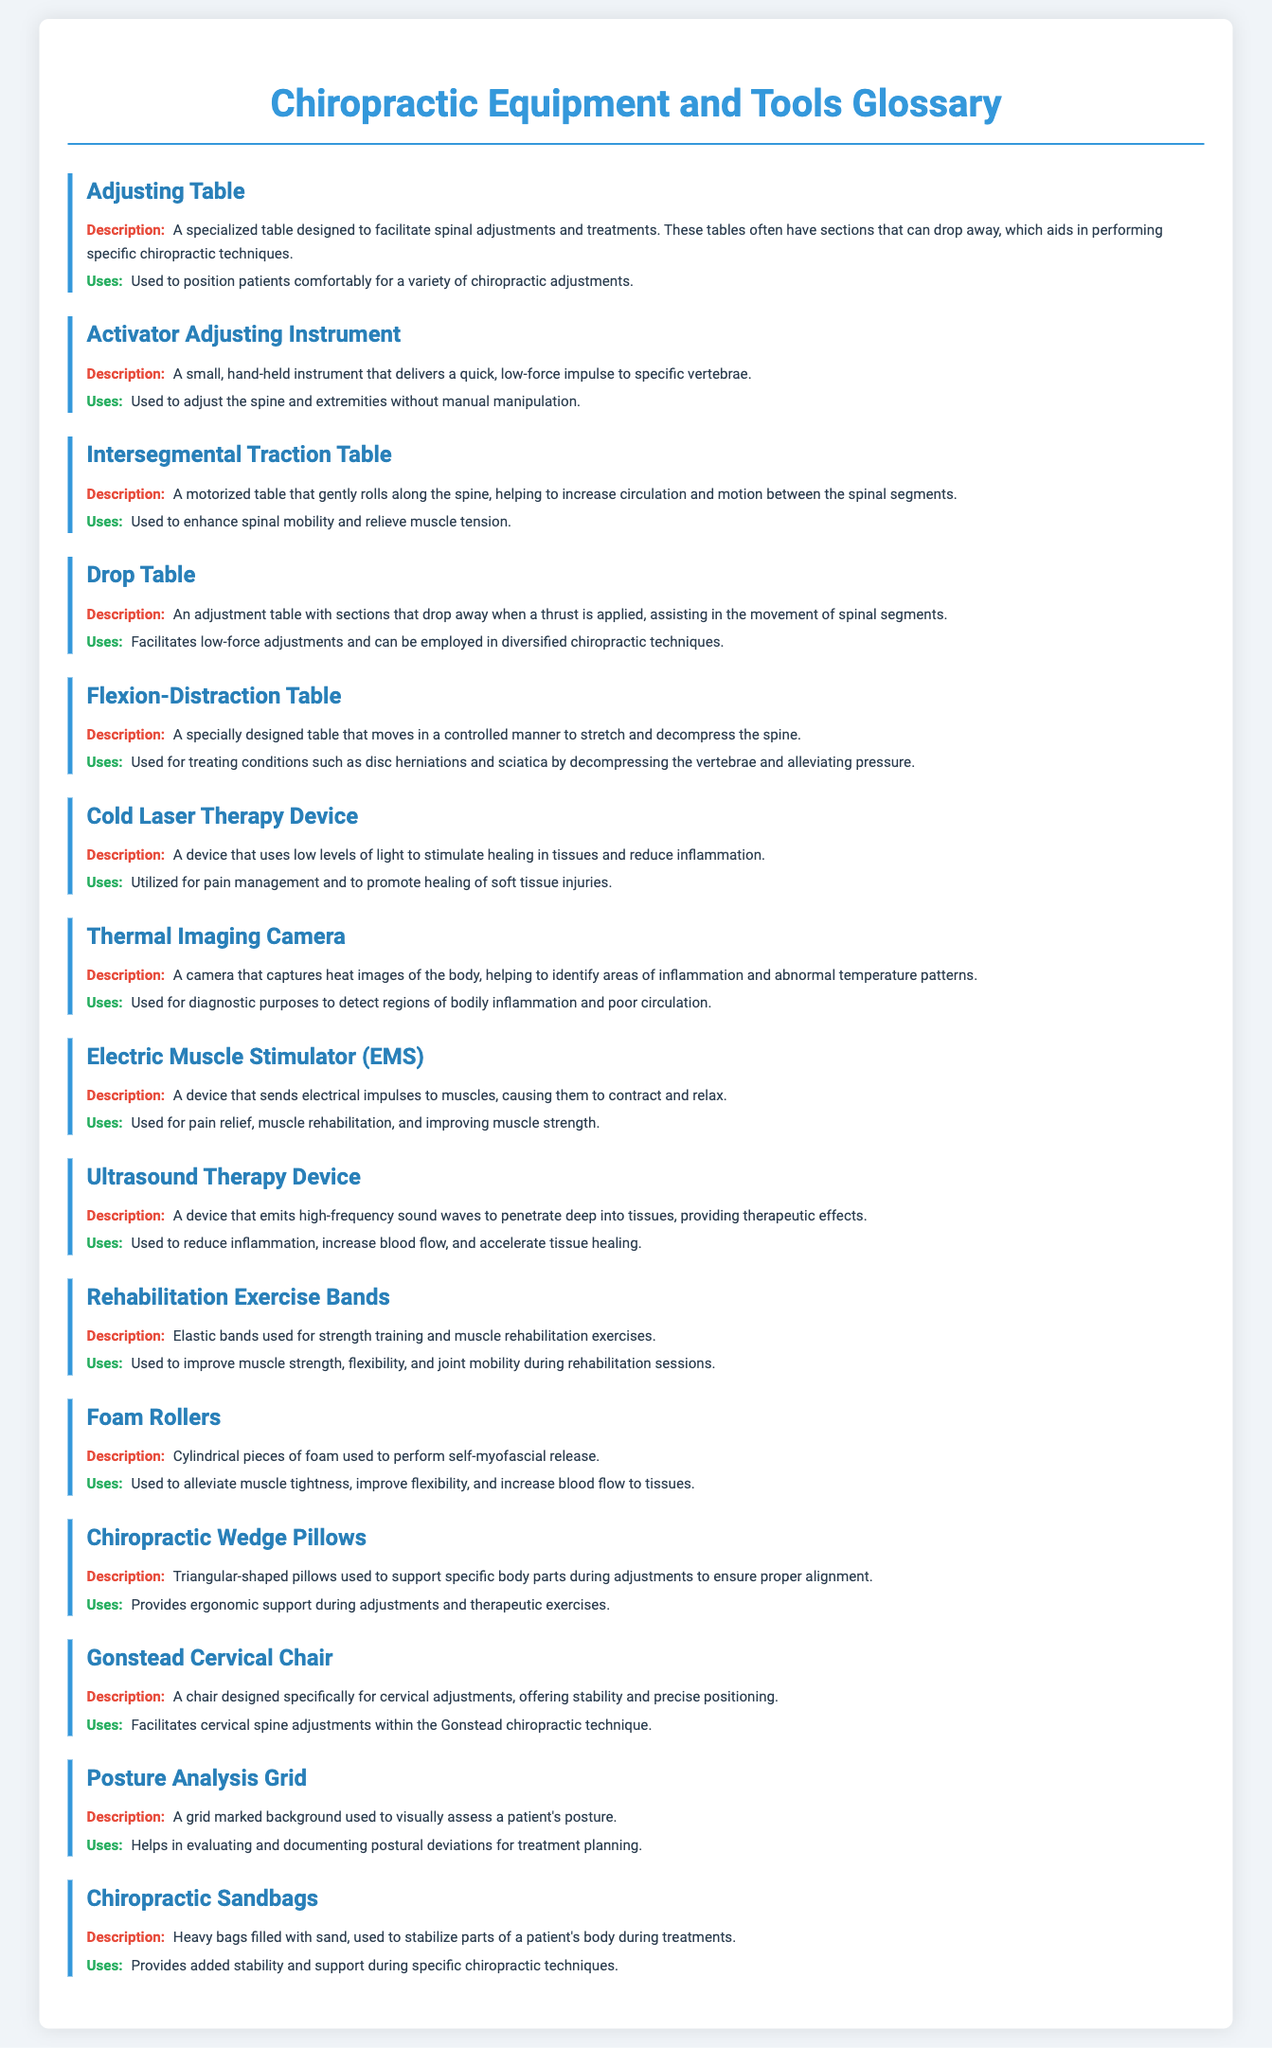What is the purpose of an Adjusting Table? The Adjusting Table is described as designed to facilitate spinal adjustments and treatments, aiding in performing specific chiropractic techniques.
Answer: Facilitate spinal adjustments What type of device is used for low-force adjustments? The Activator Adjusting Instrument is a small, hand-held instrument that delivers a quick, low-force impulse to specific vertebrae.
Answer: Activator Adjusting Instrument What type of therapy device uses low levels of light? The Cold Laser Therapy Device uses low levels of light to stimulate healing in tissues and reduce inflammation.
Answer: Cold Laser Therapy Device How does the Flexion-Distraction Table assist patients? The Flexion-Distraction Table moves in a controlled manner to stretch and decompress the spine, which helps in treating conditions like disc herniations.
Answer: Stretch and decompress the spine What is the primary use of Rehabilitation Exercise Bands? Rehabilitation Exercise Bands are used to improve muscle strength, flexibility, and joint mobility during rehabilitation sessions.
Answer: Improve muscle strength and flexibility What type of imaging does a Thermal Imaging Camera provide? The Thermal Imaging Camera captures heat images of the body to identify areas of inflammation and abnormal temperature patterns.
Answer: Heat images of the body Which tool is specifically designed for cervical adjustments? The Gonstead Cervical Chair is designed specifically for cervical adjustments, offering stability and precise positioning.
Answer: Gonstead Cervical Chair What is the function of Chiropractic Sandbags during treatments? Chiropractic Sandbags provide added stability and support during specific chiropractic techniques.
Answer: Stability and support How do Foam Rollers primarily help patients? Foam Rollers are used to alleviate muscle tightness, improve flexibility, and increase blood flow to tissues.
Answer: Alleviate muscle tightness 